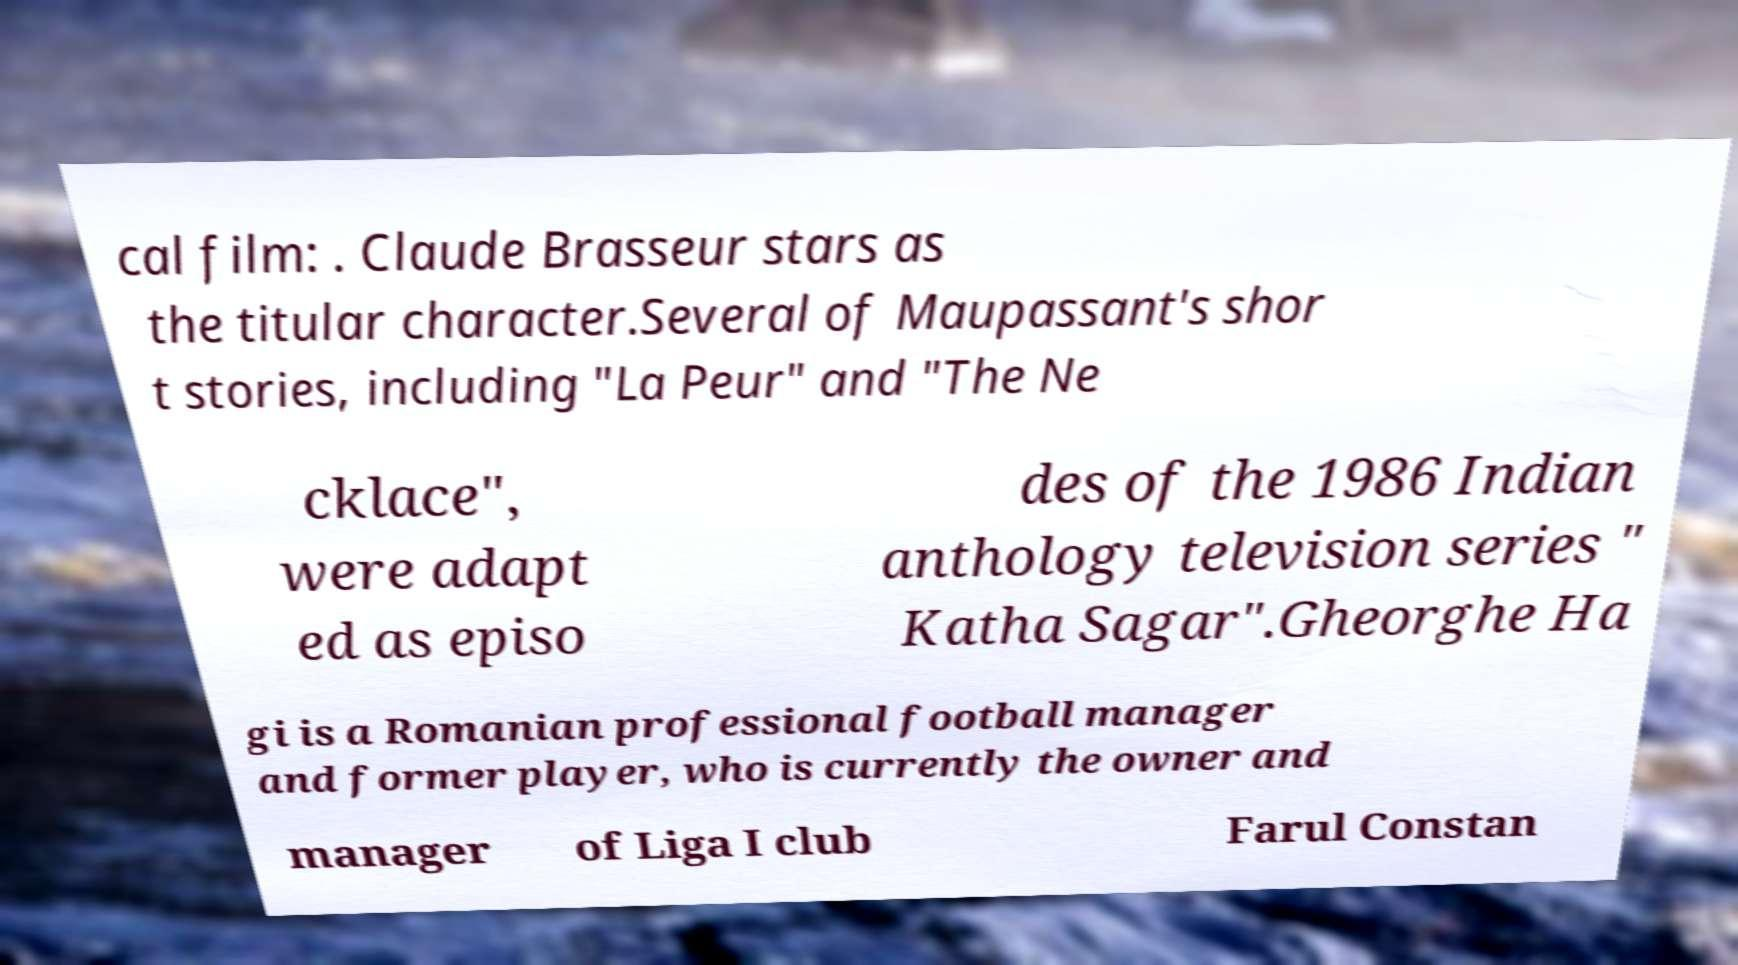Can you read and provide the text displayed in the image?This photo seems to have some interesting text. Can you extract and type it out for me? cal film: . Claude Brasseur stars as the titular character.Several of Maupassant's shor t stories, including "La Peur" and "The Ne cklace", were adapt ed as episo des of the 1986 Indian anthology television series " Katha Sagar".Gheorghe Ha gi is a Romanian professional football manager and former player, who is currently the owner and manager of Liga I club Farul Constan 